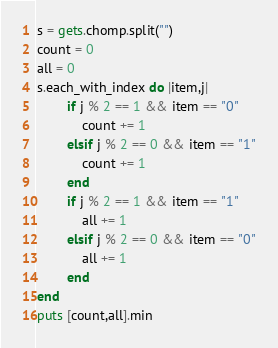<code> <loc_0><loc_0><loc_500><loc_500><_Ruby_>s = gets.chomp.split("")
count = 0
all = 0
s.each_with_index do |item,j|
        if j % 2 == 1 && item == "0"
            count += 1
        elsif j % 2 == 0 && item == "1"
            count += 1
        end
        if j % 2 == 1 && item == "1"
            all += 1
        elsif j % 2 == 0 && item == "0"
            all += 1
        end
end
puts [count,all].min</code> 